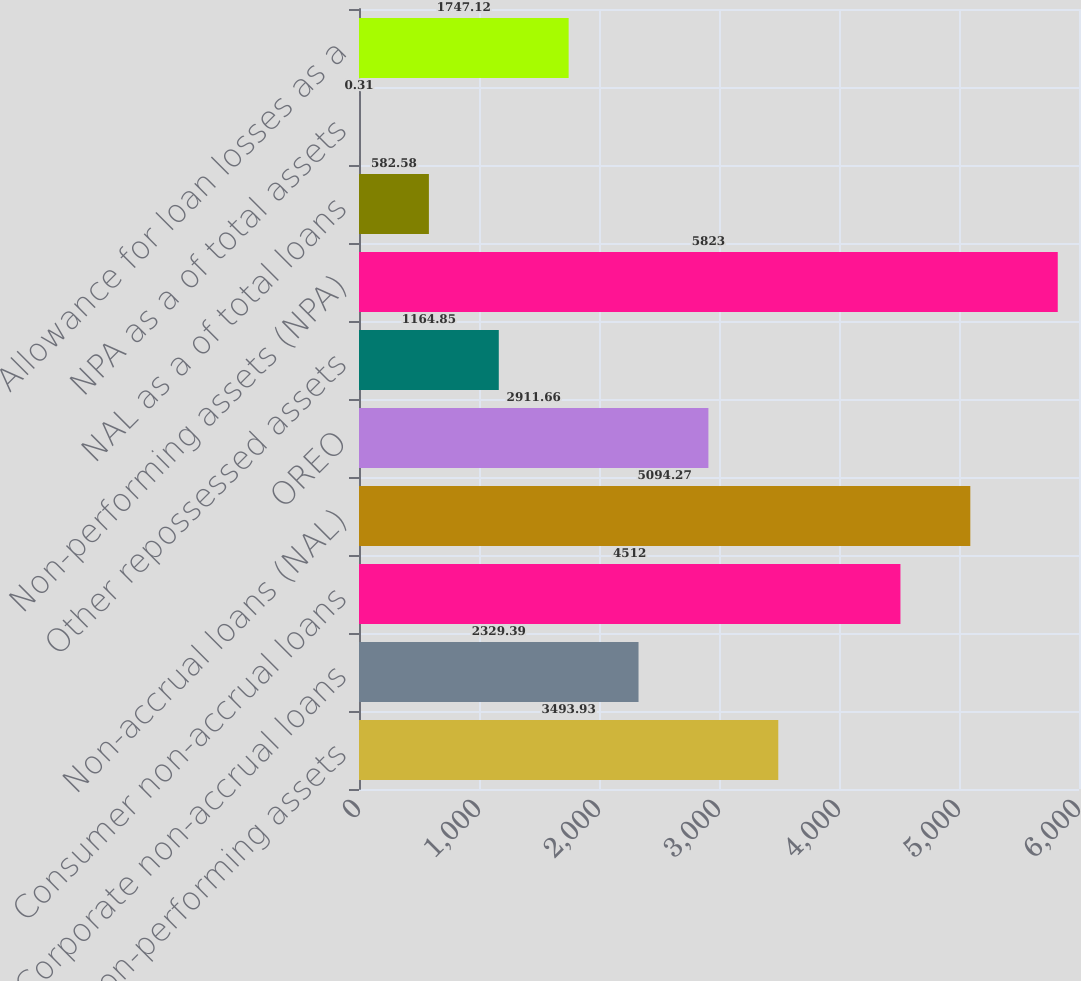Convert chart. <chart><loc_0><loc_0><loc_500><loc_500><bar_chart><fcel>Non-performing assets<fcel>Corporate non-accrual loans<fcel>Consumer non-accrual loans<fcel>Non-accrual loans (NAL)<fcel>OREO<fcel>Other repossessed assets<fcel>Non-performing assets (NPA)<fcel>NAL as a of total loans<fcel>NPA as a of total assets<fcel>Allowance for loan losses as a<nl><fcel>3493.93<fcel>2329.39<fcel>4512<fcel>5094.27<fcel>2911.66<fcel>1164.85<fcel>5823<fcel>582.58<fcel>0.31<fcel>1747.12<nl></chart> 